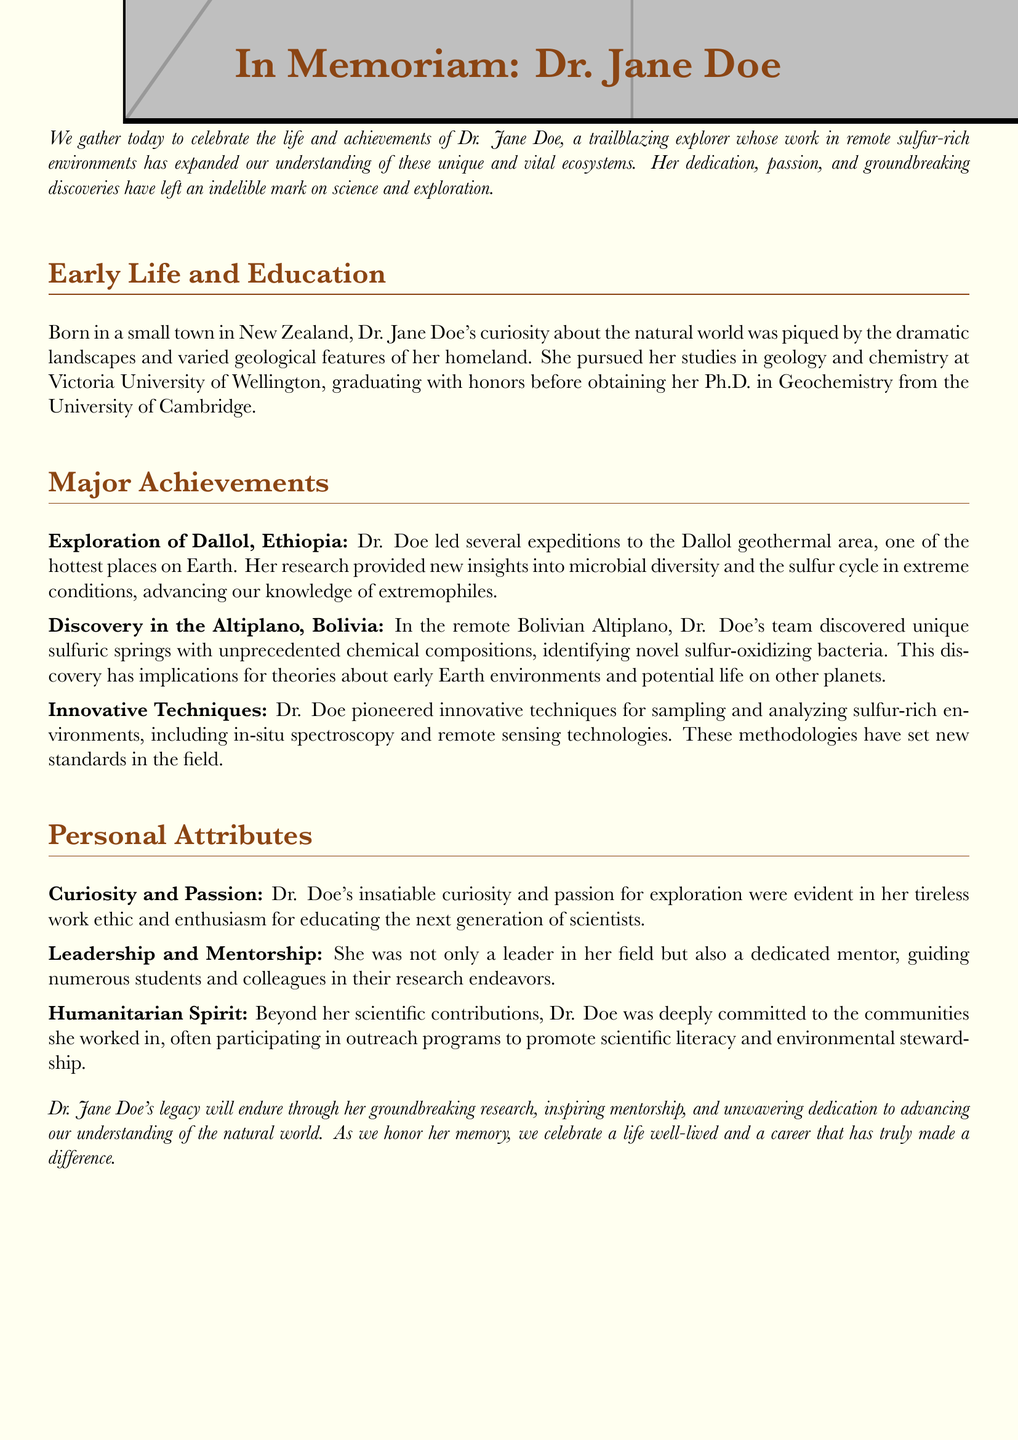What is the full name of the person being honored? The document celebrates the life and achievements of Dr. Jane Doe.
Answer: Dr. Jane Doe Where was Dr. Jane Doe born? The document states that she was born in New Zealand.
Answer: New Zealand What degree did Dr. Doe obtain from the University of Cambridge? She obtained her Ph.D. in Geochemistry from the University of Cambridge.
Answer: Ph.D. in Geochemistry What unique environment did Dr. Doe explore in Ethiopia? The document mentions her exploration of the Dallol geothermal area in Ethiopia.
Answer: Dallol geothermal area What type of bacteria did Dr. Doe’s team identify in Bolivia? The document states that they identified novel sulfur-oxidizing bacteria in the Bolivian Altiplano.
Answer: Sulfur-oxidizing bacteria How did Dr. Doe contribute to scientific research techniques? She pioneered innovative techniques for sampling and analyzing sulfur-rich environments.
Answer: Innovative techniques What attribute is associated with Dr. Doe’s work ethic? The document describes her work ethic as tireless.
Answer: Tireless In which country did Dr. Doe discover unique sulfuric springs? The document refers to her discovery of unique sulfuric springs in Bolivia.
Answer: Bolivia What role did Dr. Doe take in mentoring? She was recognized as a dedicated mentor, guiding numerous students and colleagues.
Answer: Dedicated mentor 